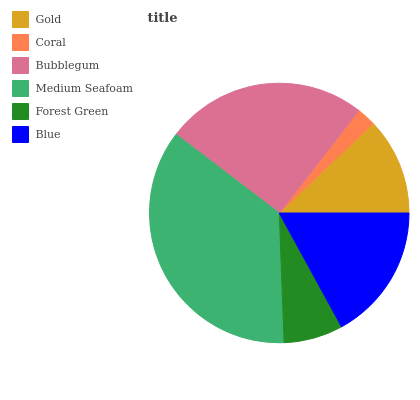Is Coral the minimum?
Answer yes or no. Yes. Is Medium Seafoam the maximum?
Answer yes or no. Yes. Is Bubblegum the minimum?
Answer yes or no. No. Is Bubblegum the maximum?
Answer yes or no. No. Is Bubblegum greater than Coral?
Answer yes or no. Yes. Is Coral less than Bubblegum?
Answer yes or no. Yes. Is Coral greater than Bubblegum?
Answer yes or no. No. Is Bubblegum less than Coral?
Answer yes or no. No. Is Blue the high median?
Answer yes or no. Yes. Is Gold the low median?
Answer yes or no. Yes. Is Forest Green the high median?
Answer yes or no. No. Is Coral the low median?
Answer yes or no. No. 